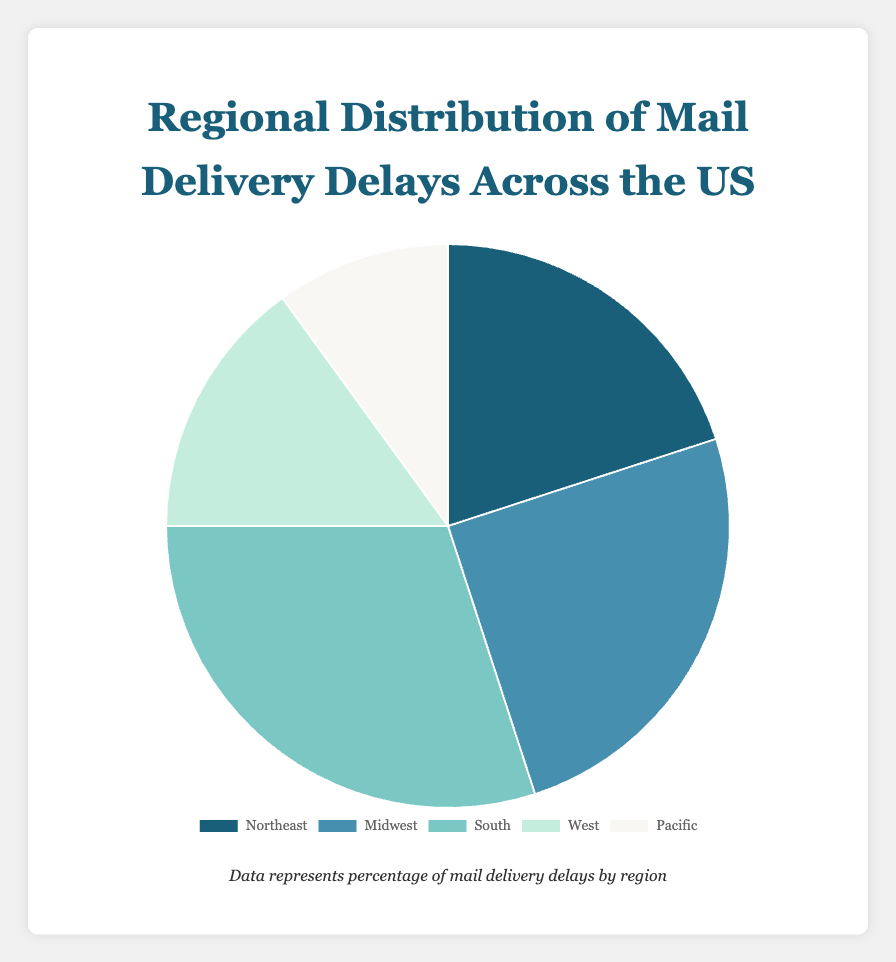What region has the highest percentage of mail delivery delays? The chart shows the percentage of delays for each region, and the South has the highest value at 30%.
Answer: South Which region has the lowest percentage of mail delivery delays? From the chart, the Pacific region is labeled with the smallest percentage of delays, which is 10%.
Answer: Pacific What is the combined percentage of mail delivery delays for the Northeast and Midwest? The Northeast has 20% delays, and the Midwest has 25%. Adding these together: 20% + 25% = 45%.
Answer: 45% Is the percentage of delays in the West less than the Northeast? The chart shows that the West has 15% delays, while the Northeast has 20%, so 15% is indeed less than 20%.
Answer: Yes What percentage of mail delivery delays does the South have compared to the Midwest? The South has 30% and the Midwest has 25%. The South has 5% more delays compared to the Midwest (30% - 25%).
Answer: 5% more What's the total percentage of mail delivery delays accounted for by the South and Pacific regions combined? The South has 30% and the Pacific has 10%. Combined, they make up 30% + 10% = 40%.
Answer: 40% Which region has a lower percentage of delivery delays, the Midwest or the West? The chart indicates that the Midwest has 25% delays, while the West has 15% delays, so the West has a lower percentage.
Answer: West What is the average percentage of mail delivery delays across all regions? Adding all percentages: 20% (Northeast) + 25% (Midwest) + 30% (South) + 15% (West) + 10% (Pacific) = 100%. There are 5 regions, so the average is 100% / 5 = 20%.
Answer: 20% 